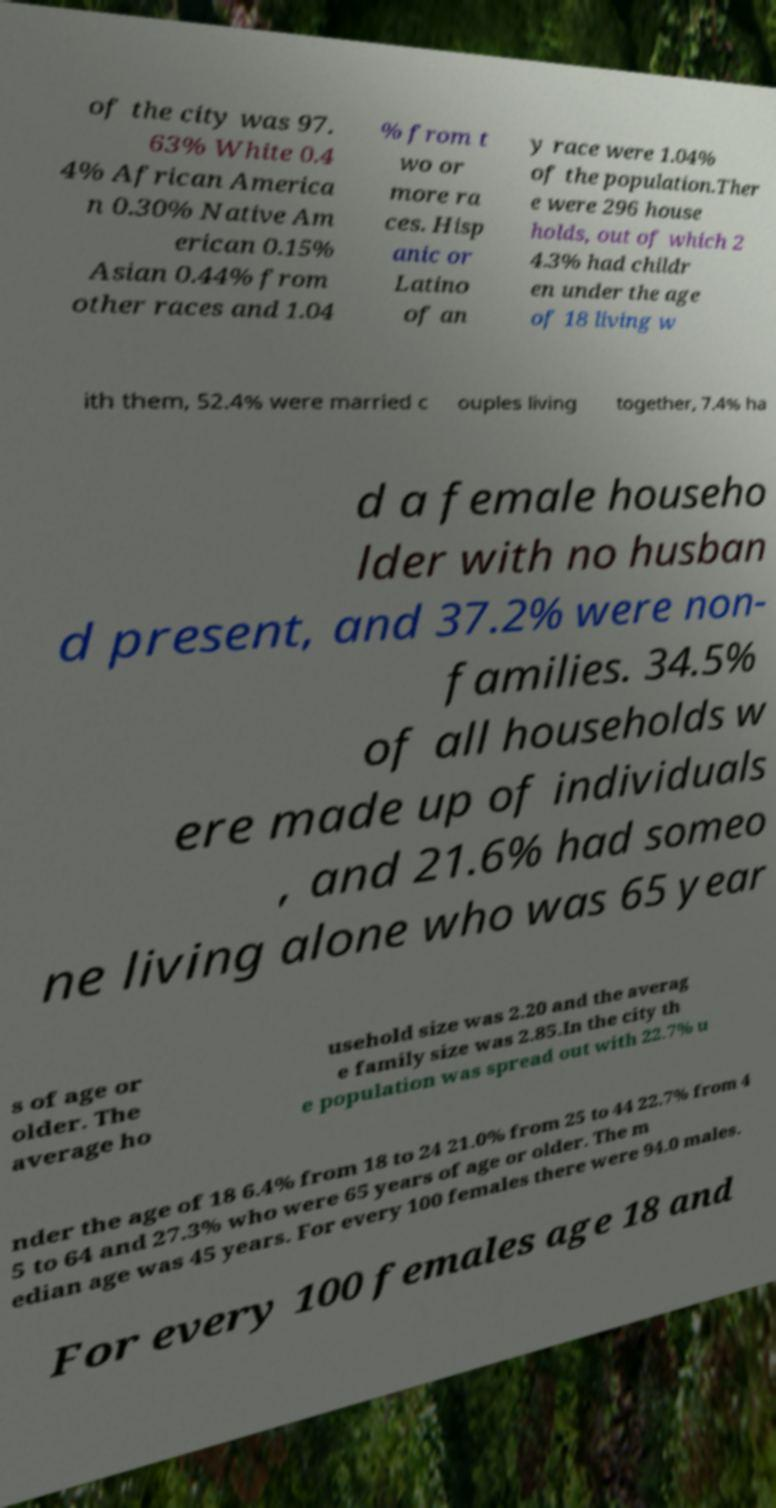Could you extract and type out the text from this image? of the city was 97. 63% White 0.4 4% African America n 0.30% Native Am erican 0.15% Asian 0.44% from other races and 1.04 % from t wo or more ra ces. Hisp anic or Latino of an y race were 1.04% of the population.Ther e were 296 house holds, out of which 2 4.3% had childr en under the age of 18 living w ith them, 52.4% were married c ouples living together, 7.4% ha d a female househo lder with no husban d present, and 37.2% were non- families. 34.5% of all households w ere made up of individuals , and 21.6% had someo ne living alone who was 65 year s of age or older. The average ho usehold size was 2.20 and the averag e family size was 2.85.In the city th e population was spread out with 22.7% u nder the age of 18 6.4% from 18 to 24 21.0% from 25 to 44 22.7% from 4 5 to 64 and 27.3% who were 65 years of age or older. The m edian age was 45 years. For every 100 females there were 94.0 males. For every 100 females age 18 and 